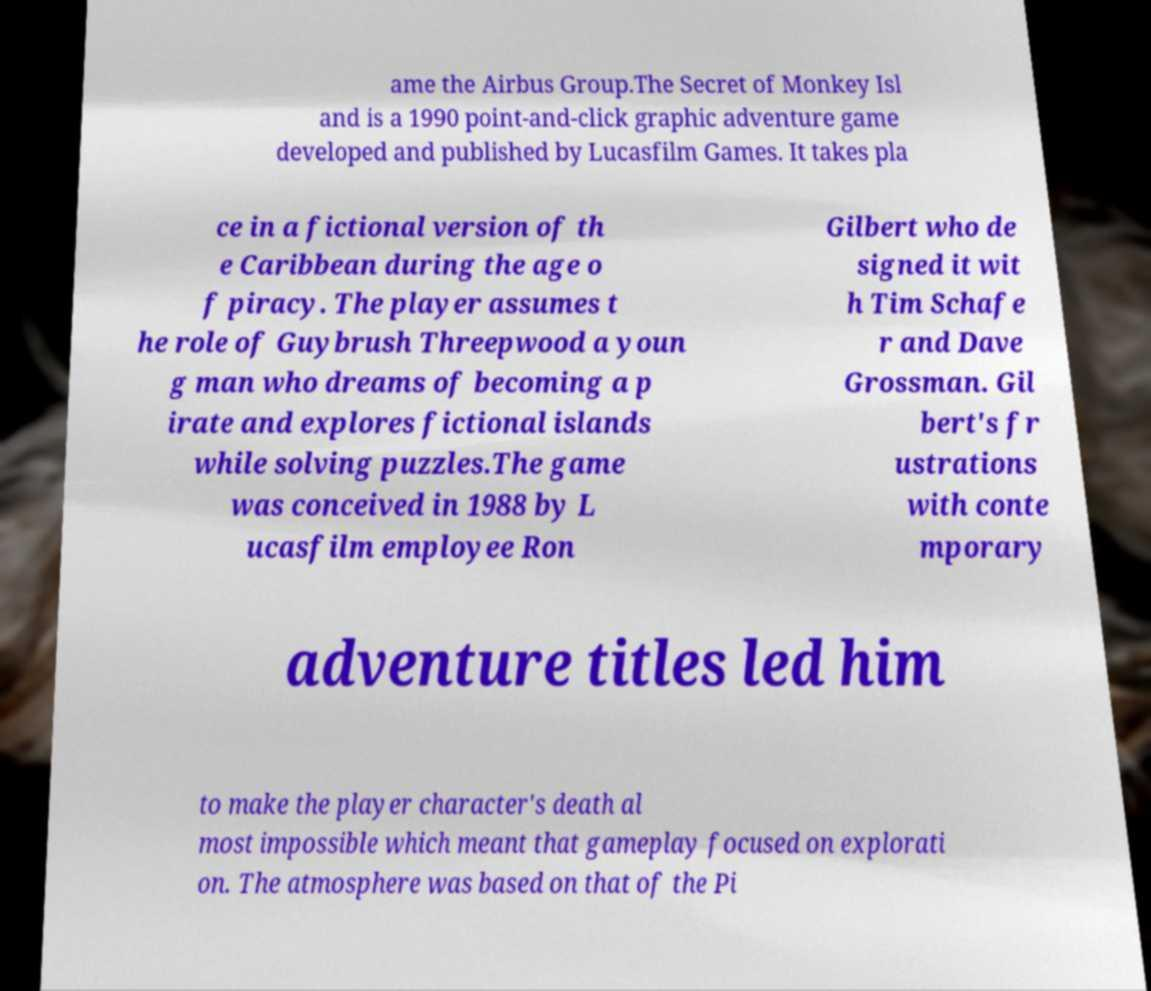I need the written content from this picture converted into text. Can you do that? ame the Airbus Group.The Secret of Monkey Isl and is a 1990 point-and-click graphic adventure game developed and published by Lucasfilm Games. It takes pla ce in a fictional version of th e Caribbean during the age o f piracy. The player assumes t he role of Guybrush Threepwood a youn g man who dreams of becoming a p irate and explores fictional islands while solving puzzles.The game was conceived in 1988 by L ucasfilm employee Ron Gilbert who de signed it wit h Tim Schafe r and Dave Grossman. Gil bert's fr ustrations with conte mporary adventure titles led him to make the player character's death al most impossible which meant that gameplay focused on explorati on. The atmosphere was based on that of the Pi 